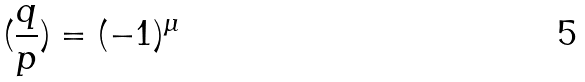<formula> <loc_0><loc_0><loc_500><loc_500>( \frac { q } { p } ) = ( - 1 ) ^ { \mu }</formula> 